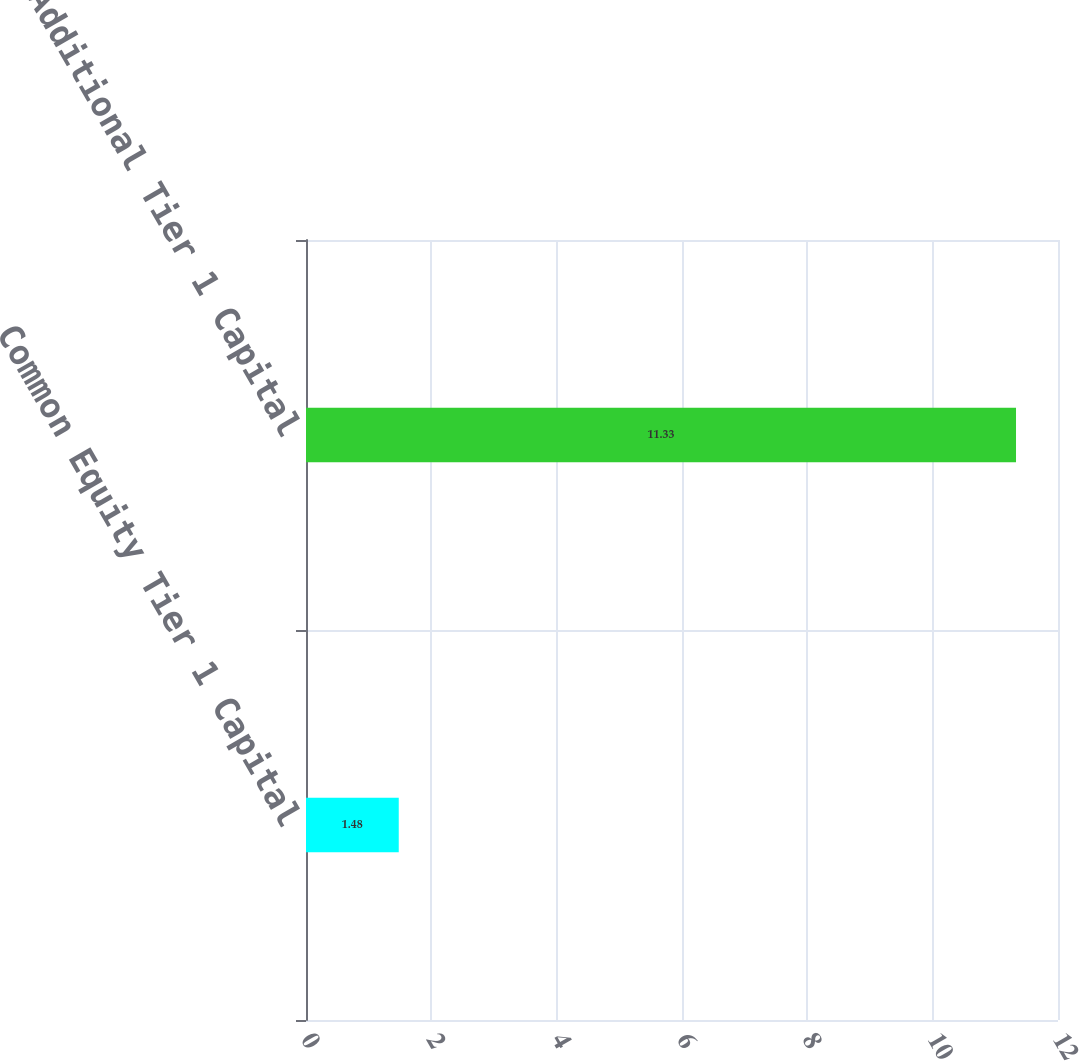<chart> <loc_0><loc_0><loc_500><loc_500><bar_chart><fcel>Common Equity Tier 1 Capital<fcel>Additional Tier 1 Capital<nl><fcel>1.48<fcel>11.33<nl></chart> 